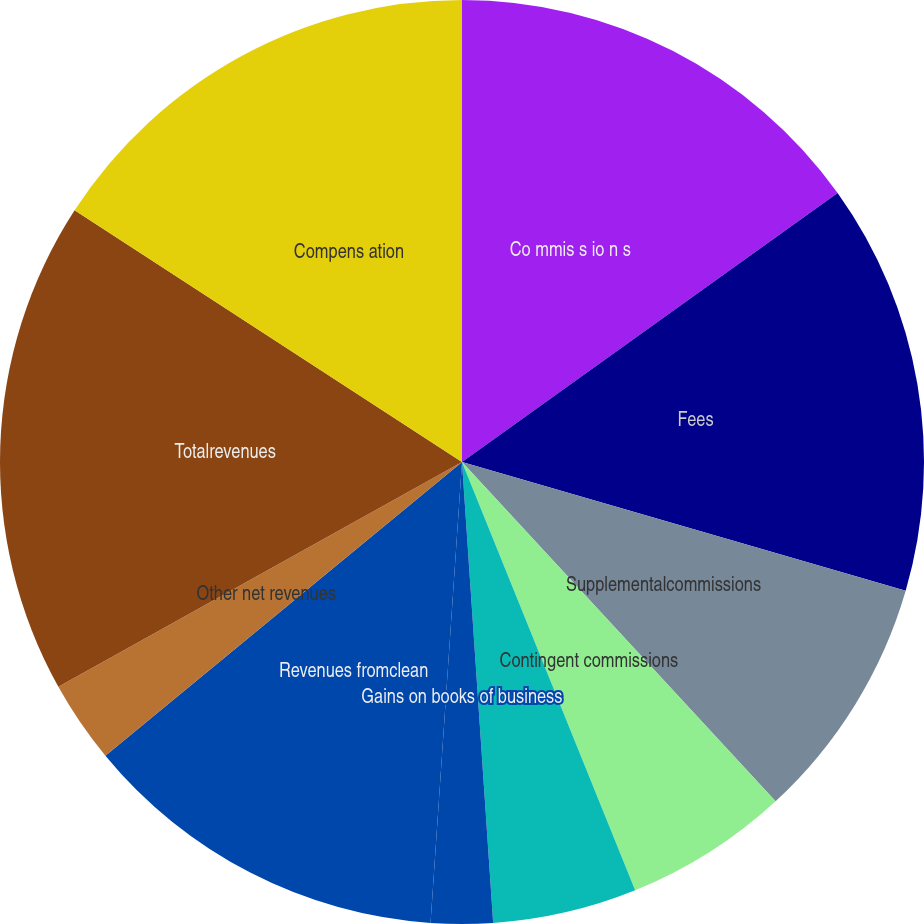Convert chart. <chart><loc_0><loc_0><loc_500><loc_500><pie_chart><fcel>Co mmis s io n s<fcel>Fees<fcel>Supplementalcommissions<fcel>Contingent commissions<fcel>In v e s t me n t in c o me<fcel>Gains on books of business<fcel>Revenues fromclean<fcel>Other net revenues<fcel>Totalrevenues<fcel>Compens ation<nl><fcel>15.11%<fcel>14.39%<fcel>8.63%<fcel>5.76%<fcel>5.04%<fcel>2.16%<fcel>12.95%<fcel>2.88%<fcel>17.26%<fcel>15.83%<nl></chart> 